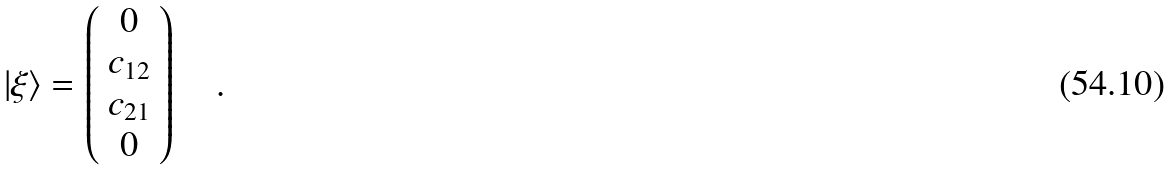<formula> <loc_0><loc_0><loc_500><loc_500>\left | \xi \right \rangle = \left ( { \begin{array} { c } 0 \\ c _ { 1 2 } \\ c _ { 2 1 } \\ 0 \\ \end{array} } \right ) \quad .</formula> 